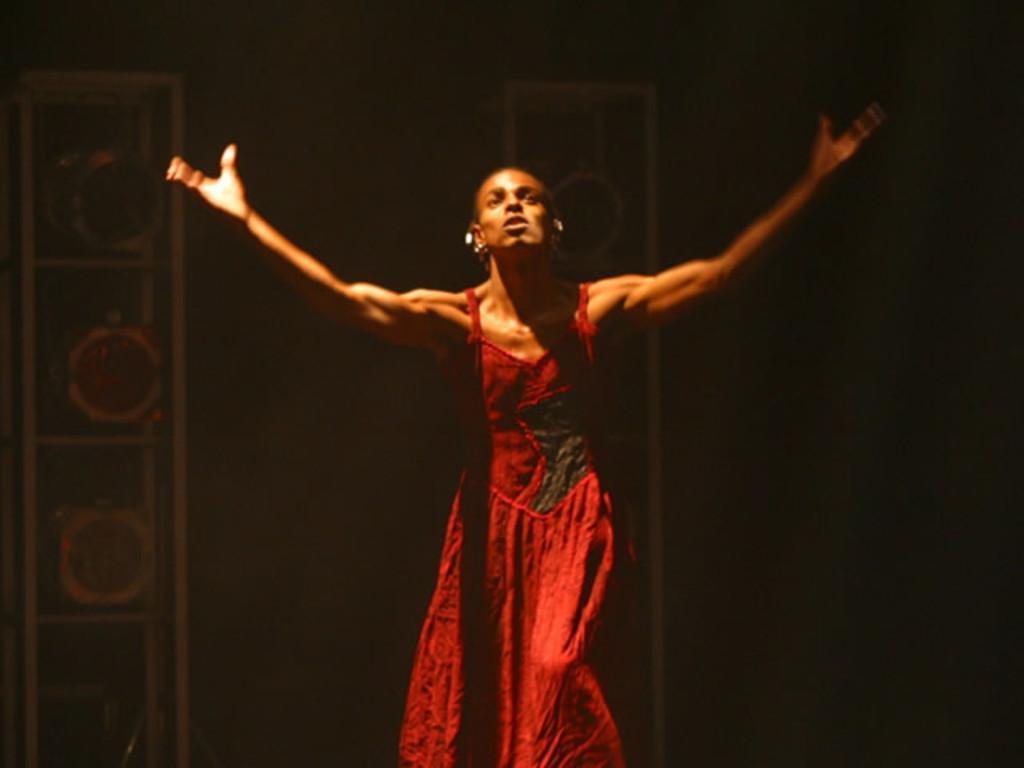In one or two sentences, can you explain what this image depicts? Here we can see a woman is standing. In the background the image is not clear but there are objects. 